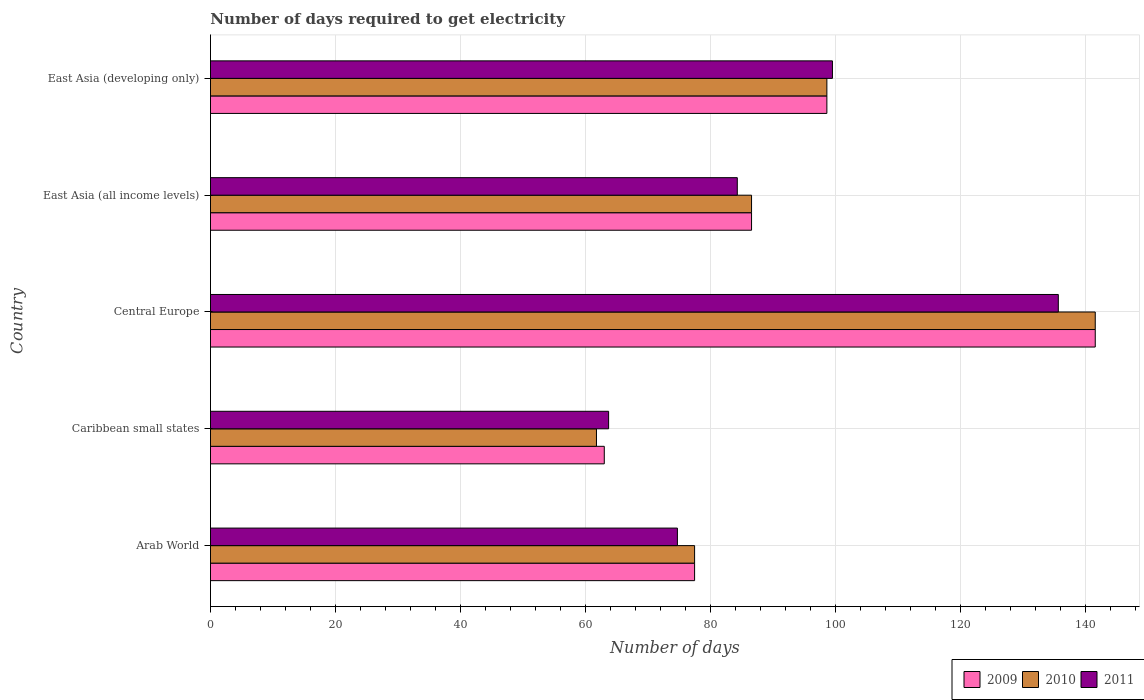How many different coloured bars are there?
Give a very brief answer. 3. How many bars are there on the 4th tick from the top?
Keep it short and to the point. 3. What is the label of the 1st group of bars from the top?
Make the answer very short. East Asia (developing only). In how many cases, is the number of bars for a given country not equal to the number of legend labels?
Ensure brevity in your answer.  0. What is the number of days required to get electricity in in 2011 in Arab World?
Give a very brief answer. 74.7. Across all countries, what is the maximum number of days required to get electricity in in 2011?
Your response must be concise. 135.64. Across all countries, what is the minimum number of days required to get electricity in in 2010?
Your answer should be compact. 61.75. In which country was the number of days required to get electricity in in 2010 maximum?
Provide a short and direct response. Central Europe. In which country was the number of days required to get electricity in in 2010 minimum?
Offer a terse response. Caribbean small states. What is the total number of days required to get electricity in in 2011 in the graph?
Keep it short and to the point. 457.81. What is the difference between the number of days required to get electricity in in 2011 in East Asia (all income levels) and that in East Asia (developing only)?
Give a very brief answer. -15.22. What is the difference between the number of days required to get electricity in in 2009 in East Asia (all income levels) and the number of days required to get electricity in in 2010 in East Asia (developing only)?
Provide a short and direct response. -12.05. What is the average number of days required to get electricity in in 2009 per country?
Offer a very short reply. 93.43. What is the difference between the number of days required to get electricity in in 2010 and number of days required to get electricity in in 2009 in Caribbean small states?
Give a very brief answer. -1.25. What is the ratio of the number of days required to get electricity in in 2009 in Central Europe to that in East Asia (all income levels)?
Your response must be concise. 1.64. Is the difference between the number of days required to get electricity in in 2010 in Arab World and Central Europe greater than the difference between the number of days required to get electricity in in 2009 in Arab World and Central Europe?
Ensure brevity in your answer.  No. What is the difference between the highest and the second highest number of days required to get electricity in in 2011?
Keep it short and to the point. 36.14. What is the difference between the highest and the lowest number of days required to get electricity in in 2010?
Give a very brief answer. 79.8. In how many countries, is the number of days required to get electricity in in 2011 greater than the average number of days required to get electricity in in 2011 taken over all countries?
Offer a very short reply. 2. Is the sum of the number of days required to get electricity in in 2010 in Arab World and Caribbean small states greater than the maximum number of days required to get electricity in in 2009 across all countries?
Offer a terse response. No. Is it the case that in every country, the sum of the number of days required to get electricity in in 2011 and number of days required to get electricity in in 2010 is greater than the number of days required to get electricity in in 2009?
Make the answer very short. Yes. Are all the bars in the graph horizontal?
Your response must be concise. Yes. What is the difference between two consecutive major ticks on the X-axis?
Provide a succinct answer. 20. Are the values on the major ticks of X-axis written in scientific E-notation?
Your answer should be compact. No. Does the graph contain any zero values?
Give a very brief answer. No. Does the graph contain grids?
Offer a terse response. Yes. How many legend labels are there?
Give a very brief answer. 3. What is the title of the graph?
Give a very brief answer. Number of days required to get electricity. What is the label or title of the X-axis?
Your answer should be compact. Number of days. What is the label or title of the Y-axis?
Provide a succinct answer. Country. What is the Number of days of 2009 in Arab World?
Offer a very short reply. 77.45. What is the Number of days of 2010 in Arab World?
Provide a short and direct response. 77.45. What is the Number of days of 2011 in Arab World?
Ensure brevity in your answer.  74.7. What is the Number of days in 2009 in Caribbean small states?
Ensure brevity in your answer.  63. What is the Number of days of 2010 in Caribbean small states?
Offer a very short reply. 61.75. What is the Number of days in 2011 in Caribbean small states?
Your response must be concise. 63.69. What is the Number of days in 2009 in Central Europe?
Provide a succinct answer. 141.55. What is the Number of days of 2010 in Central Europe?
Make the answer very short. 141.55. What is the Number of days in 2011 in Central Europe?
Provide a short and direct response. 135.64. What is the Number of days in 2009 in East Asia (all income levels)?
Give a very brief answer. 86.56. What is the Number of days of 2010 in East Asia (all income levels)?
Offer a very short reply. 86.56. What is the Number of days in 2011 in East Asia (all income levels)?
Your response must be concise. 84.28. What is the Number of days of 2009 in East Asia (developing only)?
Provide a short and direct response. 98.61. What is the Number of days of 2010 in East Asia (developing only)?
Give a very brief answer. 98.61. What is the Number of days in 2011 in East Asia (developing only)?
Offer a very short reply. 99.5. Across all countries, what is the maximum Number of days of 2009?
Your answer should be very brief. 141.55. Across all countries, what is the maximum Number of days in 2010?
Ensure brevity in your answer.  141.55. Across all countries, what is the maximum Number of days of 2011?
Ensure brevity in your answer.  135.64. Across all countries, what is the minimum Number of days of 2010?
Offer a terse response. 61.75. Across all countries, what is the minimum Number of days in 2011?
Your answer should be very brief. 63.69. What is the total Number of days of 2009 in the graph?
Ensure brevity in your answer.  467.17. What is the total Number of days of 2010 in the graph?
Offer a terse response. 465.92. What is the total Number of days of 2011 in the graph?
Ensure brevity in your answer.  457.81. What is the difference between the Number of days of 2009 in Arab World and that in Caribbean small states?
Make the answer very short. 14.45. What is the difference between the Number of days of 2010 in Arab World and that in Caribbean small states?
Your answer should be compact. 15.7. What is the difference between the Number of days of 2011 in Arab World and that in Caribbean small states?
Your response must be concise. 11.01. What is the difference between the Number of days of 2009 in Arab World and that in Central Europe?
Provide a short and direct response. -64.1. What is the difference between the Number of days of 2010 in Arab World and that in Central Europe?
Provide a short and direct response. -64.1. What is the difference between the Number of days of 2011 in Arab World and that in Central Europe?
Your answer should be very brief. -60.94. What is the difference between the Number of days of 2009 in Arab World and that in East Asia (all income levels)?
Your answer should be compact. -9.11. What is the difference between the Number of days in 2010 in Arab World and that in East Asia (all income levels)?
Provide a short and direct response. -9.11. What is the difference between the Number of days in 2011 in Arab World and that in East Asia (all income levels)?
Make the answer very short. -9.58. What is the difference between the Number of days in 2009 in Arab World and that in East Asia (developing only)?
Keep it short and to the point. -21.16. What is the difference between the Number of days in 2010 in Arab World and that in East Asia (developing only)?
Ensure brevity in your answer.  -21.16. What is the difference between the Number of days in 2011 in Arab World and that in East Asia (developing only)?
Give a very brief answer. -24.8. What is the difference between the Number of days of 2009 in Caribbean small states and that in Central Europe?
Provide a succinct answer. -78.55. What is the difference between the Number of days in 2010 in Caribbean small states and that in Central Europe?
Provide a short and direct response. -79.8. What is the difference between the Number of days in 2011 in Caribbean small states and that in Central Europe?
Your response must be concise. -71.94. What is the difference between the Number of days of 2009 in Caribbean small states and that in East Asia (all income levels)?
Ensure brevity in your answer.  -23.56. What is the difference between the Number of days in 2010 in Caribbean small states and that in East Asia (all income levels)?
Offer a terse response. -24.81. What is the difference between the Number of days of 2011 in Caribbean small states and that in East Asia (all income levels)?
Offer a terse response. -20.59. What is the difference between the Number of days of 2009 in Caribbean small states and that in East Asia (developing only)?
Offer a terse response. -35.61. What is the difference between the Number of days of 2010 in Caribbean small states and that in East Asia (developing only)?
Offer a very short reply. -36.86. What is the difference between the Number of days in 2011 in Caribbean small states and that in East Asia (developing only)?
Your answer should be very brief. -35.81. What is the difference between the Number of days of 2009 in Central Europe and that in East Asia (all income levels)?
Offer a very short reply. 54.99. What is the difference between the Number of days of 2010 in Central Europe and that in East Asia (all income levels)?
Keep it short and to the point. 54.99. What is the difference between the Number of days in 2011 in Central Europe and that in East Asia (all income levels)?
Give a very brief answer. 51.36. What is the difference between the Number of days of 2009 in Central Europe and that in East Asia (developing only)?
Keep it short and to the point. 42.93. What is the difference between the Number of days of 2010 in Central Europe and that in East Asia (developing only)?
Offer a terse response. 42.93. What is the difference between the Number of days in 2011 in Central Europe and that in East Asia (developing only)?
Provide a succinct answer. 36.14. What is the difference between the Number of days of 2009 in East Asia (all income levels) and that in East Asia (developing only)?
Offer a very short reply. -12.05. What is the difference between the Number of days of 2010 in East Asia (all income levels) and that in East Asia (developing only)?
Your response must be concise. -12.05. What is the difference between the Number of days in 2011 in East Asia (all income levels) and that in East Asia (developing only)?
Your answer should be very brief. -15.22. What is the difference between the Number of days in 2009 in Arab World and the Number of days in 2011 in Caribbean small states?
Your response must be concise. 13.76. What is the difference between the Number of days in 2010 in Arab World and the Number of days in 2011 in Caribbean small states?
Ensure brevity in your answer.  13.76. What is the difference between the Number of days of 2009 in Arab World and the Number of days of 2010 in Central Europe?
Make the answer very short. -64.1. What is the difference between the Number of days of 2009 in Arab World and the Number of days of 2011 in Central Europe?
Make the answer very short. -58.19. What is the difference between the Number of days of 2010 in Arab World and the Number of days of 2011 in Central Europe?
Give a very brief answer. -58.19. What is the difference between the Number of days in 2009 in Arab World and the Number of days in 2010 in East Asia (all income levels)?
Provide a succinct answer. -9.11. What is the difference between the Number of days in 2009 in Arab World and the Number of days in 2011 in East Asia (all income levels)?
Your answer should be very brief. -6.83. What is the difference between the Number of days in 2010 in Arab World and the Number of days in 2011 in East Asia (all income levels)?
Provide a succinct answer. -6.83. What is the difference between the Number of days in 2009 in Arab World and the Number of days in 2010 in East Asia (developing only)?
Your answer should be very brief. -21.16. What is the difference between the Number of days of 2009 in Arab World and the Number of days of 2011 in East Asia (developing only)?
Keep it short and to the point. -22.05. What is the difference between the Number of days in 2010 in Arab World and the Number of days in 2011 in East Asia (developing only)?
Ensure brevity in your answer.  -22.05. What is the difference between the Number of days of 2009 in Caribbean small states and the Number of days of 2010 in Central Europe?
Offer a very short reply. -78.55. What is the difference between the Number of days of 2009 in Caribbean small states and the Number of days of 2011 in Central Europe?
Provide a short and direct response. -72.64. What is the difference between the Number of days in 2010 in Caribbean small states and the Number of days in 2011 in Central Europe?
Offer a very short reply. -73.89. What is the difference between the Number of days in 2009 in Caribbean small states and the Number of days in 2010 in East Asia (all income levels)?
Offer a very short reply. -23.56. What is the difference between the Number of days in 2009 in Caribbean small states and the Number of days in 2011 in East Asia (all income levels)?
Keep it short and to the point. -21.28. What is the difference between the Number of days of 2010 in Caribbean small states and the Number of days of 2011 in East Asia (all income levels)?
Your answer should be compact. -22.53. What is the difference between the Number of days of 2009 in Caribbean small states and the Number of days of 2010 in East Asia (developing only)?
Provide a short and direct response. -35.61. What is the difference between the Number of days of 2009 in Caribbean small states and the Number of days of 2011 in East Asia (developing only)?
Offer a very short reply. -36.5. What is the difference between the Number of days in 2010 in Caribbean small states and the Number of days in 2011 in East Asia (developing only)?
Your response must be concise. -37.75. What is the difference between the Number of days in 2009 in Central Europe and the Number of days in 2010 in East Asia (all income levels)?
Ensure brevity in your answer.  54.99. What is the difference between the Number of days in 2009 in Central Europe and the Number of days in 2011 in East Asia (all income levels)?
Keep it short and to the point. 57.27. What is the difference between the Number of days of 2010 in Central Europe and the Number of days of 2011 in East Asia (all income levels)?
Make the answer very short. 57.27. What is the difference between the Number of days of 2009 in Central Europe and the Number of days of 2010 in East Asia (developing only)?
Keep it short and to the point. 42.93. What is the difference between the Number of days in 2009 in Central Europe and the Number of days in 2011 in East Asia (developing only)?
Your answer should be compact. 42.05. What is the difference between the Number of days of 2010 in Central Europe and the Number of days of 2011 in East Asia (developing only)?
Your answer should be very brief. 42.05. What is the difference between the Number of days in 2009 in East Asia (all income levels) and the Number of days in 2010 in East Asia (developing only)?
Ensure brevity in your answer.  -12.05. What is the difference between the Number of days in 2009 in East Asia (all income levels) and the Number of days in 2011 in East Asia (developing only)?
Your answer should be very brief. -12.94. What is the difference between the Number of days of 2010 in East Asia (all income levels) and the Number of days of 2011 in East Asia (developing only)?
Your answer should be compact. -12.94. What is the average Number of days of 2009 per country?
Provide a short and direct response. 93.43. What is the average Number of days in 2010 per country?
Your answer should be compact. 93.18. What is the average Number of days of 2011 per country?
Give a very brief answer. 91.56. What is the difference between the Number of days of 2009 and Number of days of 2010 in Arab World?
Offer a terse response. 0. What is the difference between the Number of days of 2009 and Number of days of 2011 in Arab World?
Provide a succinct answer. 2.75. What is the difference between the Number of days in 2010 and Number of days in 2011 in Arab World?
Make the answer very short. 2.75. What is the difference between the Number of days of 2009 and Number of days of 2011 in Caribbean small states?
Your answer should be very brief. -0.69. What is the difference between the Number of days in 2010 and Number of days in 2011 in Caribbean small states?
Provide a succinct answer. -1.94. What is the difference between the Number of days in 2009 and Number of days in 2010 in Central Europe?
Offer a very short reply. 0. What is the difference between the Number of days of 2009 and Number of days of 2011 in Central Europe?
Offer a very short reply. 5.91. What is the difference between the Number of days in 2010 and Number of days in 2011 in Central Europe?
Give a very brief answer. 5.91. What is the difference between the Number of days in 2009 and Number of days in 2011 in East Asia (all income levels)?
Your answer should be compact. 2.28. What is the difference between the Number of days in 2010 and Number of days in 2011 in East Asia (all income levels)?
Make the answer very short. 2.28. What is the difference between the Number of days of 2009 and Number of days of 2010 in East Asia (developing only)?
Your answer should be very brief. 0. What is the difference between the Number of days in 2009 and Number of days in 2011 in East Asia (developing only)?
Your answer should be compact. -0.89. What is the difference between the Number of days in 2010 and Number of days in 2011 in East Asia (developing only)?
Make the answer very short. -0.89. What is the ratio of the Number of days of 2009 in Arab World to that in Caribbean small states?
Keep it short and to the point. 1.23. What is the ratio of the Number of days of 2010 in Arab World to that in Caribbean small states?
Provide a succinct answer. 1.25. What is the ratio of the Number of days of 2011 in Arab World to that in Caribbean small states?
Your answer should be very brief. 1.17. What is the ratio of the Number of days of 2009 in Arab World to that in Central Europe?
Provide a succinct answer. 0.55. What is the ratio of the Number of days in 2010 in Arab World to that in Central Europe?
Provide a succinct answer. 0.55. What is the ratio of the Number of days in 2011 in Arab World to that in Central Europe?
Your answer should be very brief. 0.55. What is the ratio of the Number of days of 2009 in Arab World to that in East Asia (all income levels)?
Ensure brevity in your answer.  0.89. What is the ratio of the Number of days of 2010 in Arab World to that in East Asia (all income levels)?
Provide a short and direct response. 0.89. What is the ratio of the Number of days of 2011 in Arab World to that in East Asia (all income levels)?
Your response must be concise. 0.89. What is the ratio of the Number of days in 2009 in Arab World to that in East Asia (developing only)?
Provide a succinct answer. 0.79. What is the ratio of the Number of days in 2010 in Arab World to that in East Asia (developing only)?
Keep it short and to the point. 0.79. What is the ratio of the Number of days in 2011 in Arab World to that in East Asia (developing only)?
Offer a very short reply. 0.75. What is the ratio of the Number of days in 2009 in Caribbean small states to that in Central Europe?
Provide a succinct answer. 0.45. What is the ratio of the Number of days in 2010 in Caribbean small states to that in Central Europe?
Offer a very short reply. 0.44. What is the ratio of the Number of days of 2011 in Caribbean small states to that in Central Europe?
Offer a very short reply. 0.47. What is the ratio of the Number of days in 2009 in Caribbean small states to that in East Asia (all income levels)?
Ensure brevity in your answer.  0.73. What is the ratio of the Number of days in 2010 in Caribbean small states to that in East Asia (all income levels)?
Your answer should be compact. 0.71. What is the ratio of the Number of days of 2011 in Caribbean small states to that in East Asia (all income levels)?
Offer a terse response. 0.76. What is the ratio of the Number of days of 2009 in Caribbean small states to that in East Asia (developing only)?
Provide a short and direct response. 0.64. What is the ratio of the Number of days in 2010 in Caribbean small states to that in East Asia (developing only)?
Keep it short and to the point. 0.63. What is the ratio of the Number of days of 2011 in Caribbean small states to that in East Asia (developing only)?
Provide a short and direct response. 0.64. What is the ratio of the Number of days of 2009 in Central Europe to that in East Asia (all income levels)?
Offer a terse response. 1.64. What is the ratio of the Number of days in 2010 in Central Europe to that in East Asia (all income levels)?
Your answer should be very brief. 1.64. What is the ratio of the Number of days in 2011 in Central Europe to that in East Asia (all income levels)?
Your response must be concise. 1.61. What is the ratio of the Number of days in 2009 in Central Europe to that in East Asia (developing only)?
Your response must be concise. 1.44. What is the ratio of the Number of days of 2010 in Central Europe to that in East Asia (developing only)?
Keep it short and to the point. 1.44. What is the ratio of the Number of days in 2011 in Central Europe to that in East Asia (developing only)?
Keep it short and to the point. 1.36. What is the ratio of the Number of days of 2009 in East Asia (all income levels) to that in East Asia (developing only)?
Make the answer very short. 0.88. What is the ratio of the Number of days in 2010 in East Asia (all income levels) to that in East Asia (developing only)?
Keep it short and to the point. 0.88. What is the ratio of the Number of days of 2011 in East Asia (all income levels) to that in East Asia (developing only)?
Give a very brief answer. 0.85. What is the difference between the highest and the second highest Number of days of 2009?
Your response must be concise. 42.93. What is the difference between the highest and the second highest Number of days of 2010?
Make the answer very short. 42.93. What is the difference between the highest and the second highest Number of days in 2011?
Keep it short and to the point. 36.14. What is the difference between the highest and the lowest Number of days in 2009?
Provide a succinct answer. 78.55. What is the difference between the highest and the lowest Number of days in 2010?
Keep it short and to the point. 79.8. What is the difference between the highest and the lowest Number of days in 2011?
Make the answer very short. 71.94. 